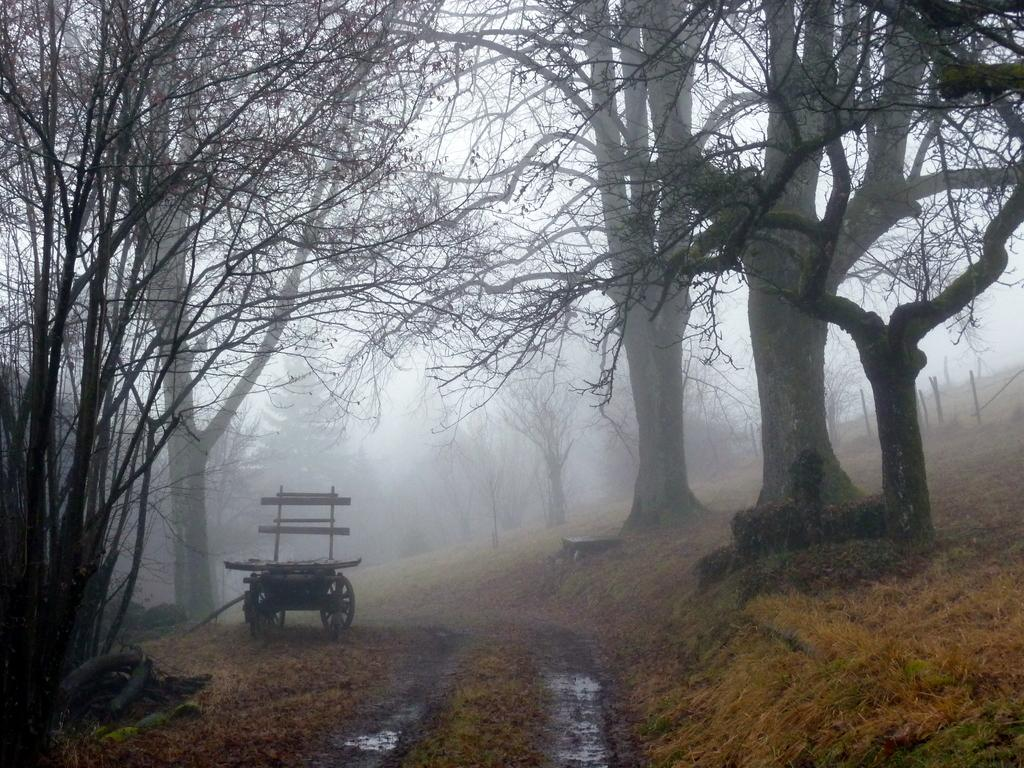What can be seen in the foreground of the image? There is a path in the foreground of the image. What is located on either side of the path? Trees are present on either side of the path. What type of vegetation is visible along the path? Grass is visible along the path. What is visible in the background of the image? There are trees and the sky in the background of the image. Where is the crate located in the image? There is no crate present in the image. Can you describe the snail's movement along the path in the image? There is no snail present in the image, so its movement cannot be described. 